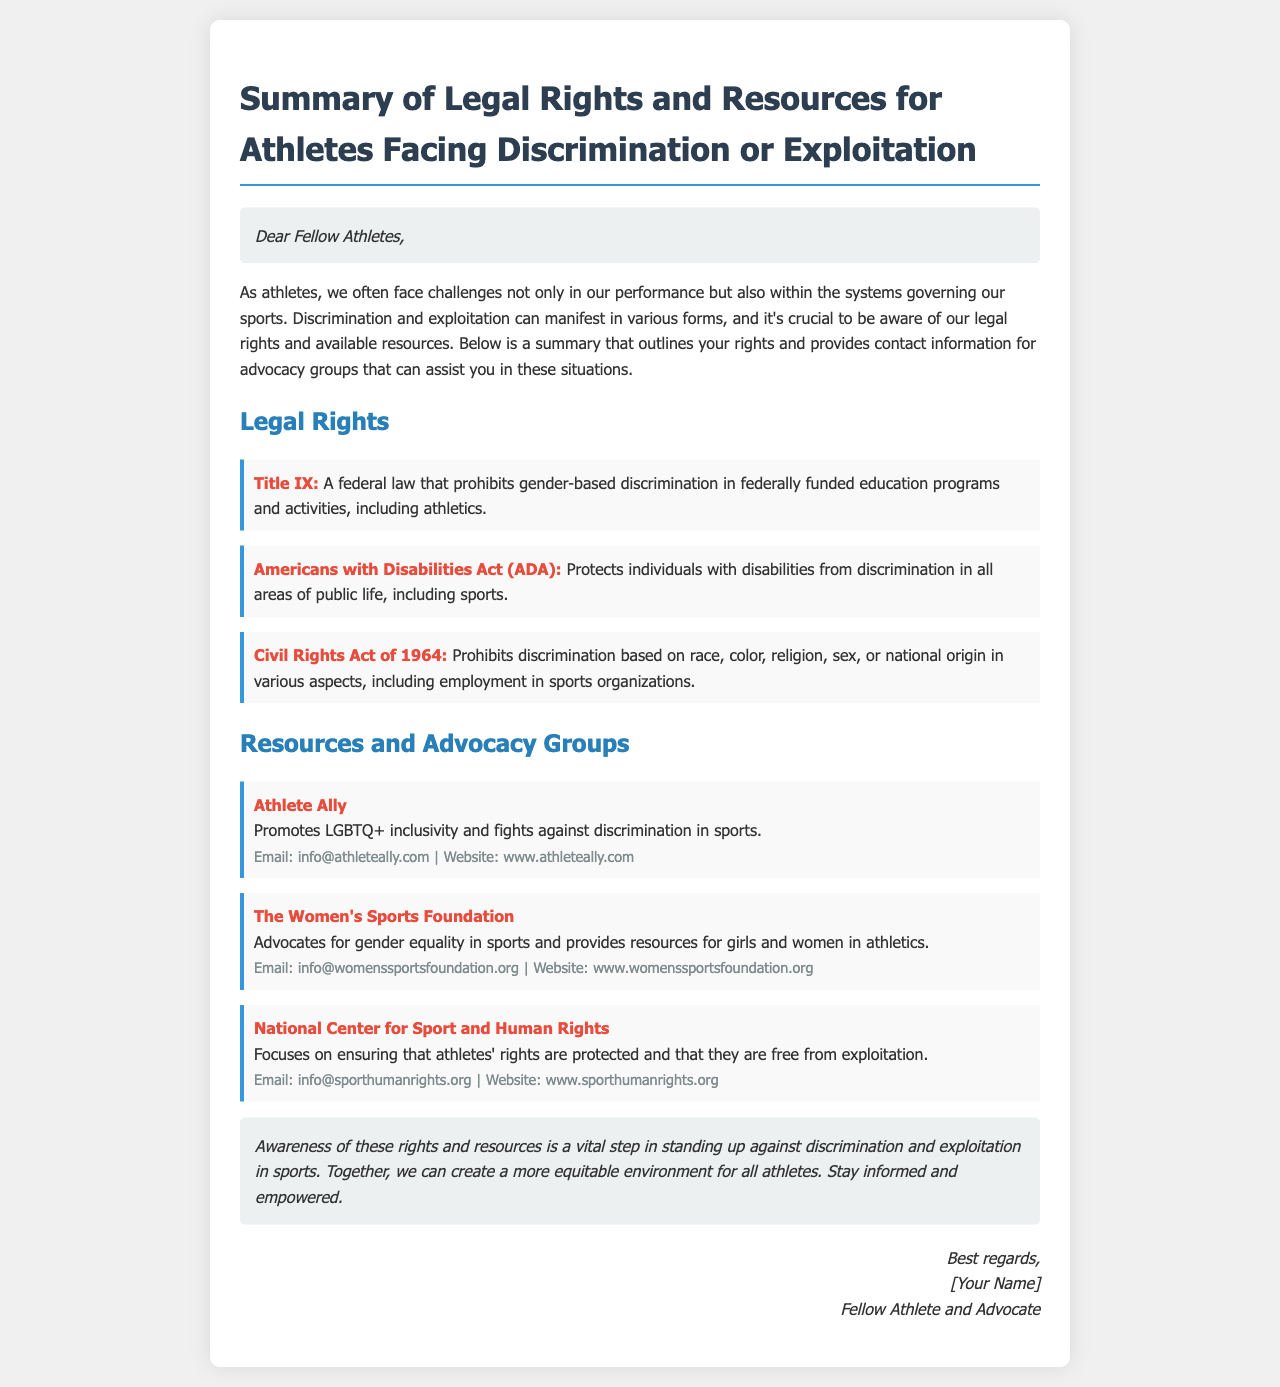What is Title IX? Title IX is defined in the document as a federal law that prohibits gender-based discrimination in federally funded education programs and activities, including athletics.
Answer: A federal law prohibiting gender-based discrimination Who does the Americans with Disabilities Act (ADA) protect? The document states that the ADA protects individuals with disabilities from discrimination in all areas of public life, including sports.
Answer: Individuals with disabilities What is the focus of the National Center for Sport and Human Rights? The document indicates that this organization focuses on ensuring that athletes' rights are protected and that they are free from exploitation.
Answer: Protecting athletes' rights Which advocacy group promotes LGBTQ+ inclusivity? The document lists Athlete Ally as the organization that promotes LGBTQ+ inclusivity and fights against discrimination in sports.
Answer: Athlete Ally How can you contact The Women's Sports Foundation? The document provides an email and website for contacting The Women's Sports Foundation, which includes "info@womenssportsfoundation.org" and "www.womenssportsfoundation.org".
Answer: Email: info@womenssportsfoundation.org What type of document is this? The document is a summary that outlines legal rights and resources for athletes facing discrimination or exploitation.
Answer: Summary of legal rights and resources What is the overall aim of the document? The document aims to raise awareness of athletes' rights and available resources to combat discrimination and exploitation in sports.
Answer: Raising awareness What is meant by exploitation in sports according to the document? The document suggests that exploitation refers to situations where athletes may be taken advantage of, particularly concerning their rights.
Answer: Taking advantage of athletes' rights 